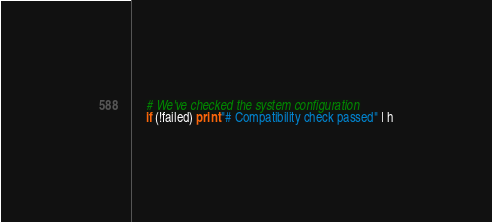<code> <loc_0><loc_0><loc_500><loc_500><_Awk_>	# We've checked the system configuration
	if (!failed) print "# Compatibility check passed" | h</code> 